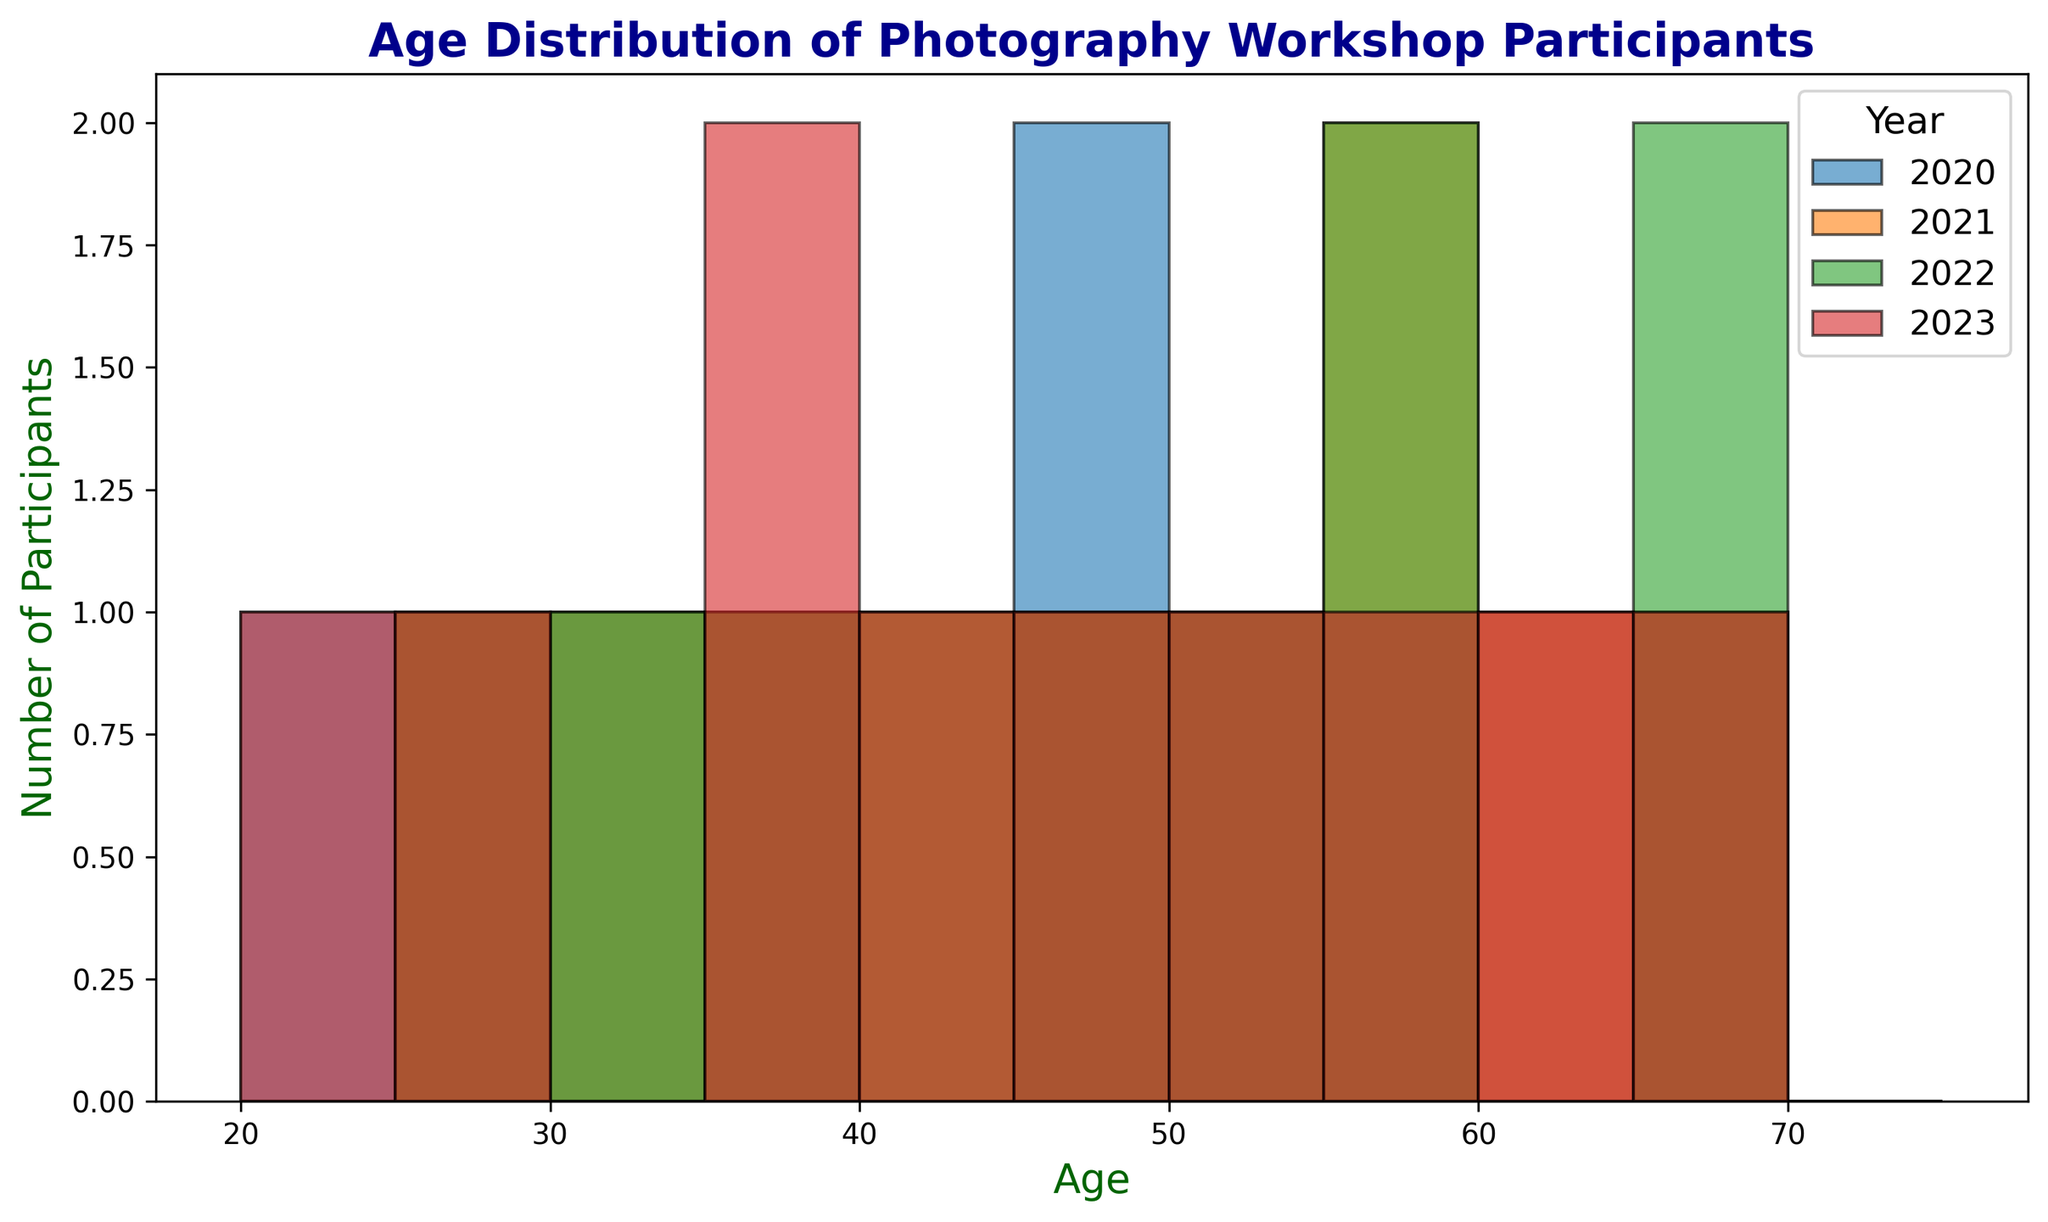What is the most common age group for participants in 2020? Look at the histogram for the year 2020 and identify which age bin has the highest bar. This represents the most common age group.
Answer: 45-50 Which year had the highest number of participants in the age group 55-60? Compare the heights of the bars representing the age group 55-60 for each year. The year with the tallest bar is the answer.
Answer: 2021 What is the smallest age group with participants across all years combined? Review the histogram across all years and find the shortest bar, which will indicate the smallest age group.
Answer: 20-25 Which year has a higher number of participants aged 40-45, 2021 or 2023? Compare the heights of the bars for the age group 40-45 between the years 2021 and 2023. The year with a taller bar has more participants.
Answer: 2023 How many participants were there in the 30-35 age group in 2020 and 2021 combined? Find the heights of the bars for the age group 30-35 in 2020 and 2021, and add them together to get the total number of participants.
Answer: 2 In which age group did the number of participants decrease from 2021 to 2022? Look at the changes in heights of the bars in each age group from 2021 to 2022 and identify the age group where the height is lower in 2022 than in 2021.
Answer: 55-60 For the 50-55 age group, compare the number of participants across all years and identify the year with the least participants. Assess the bar heights for the 50-55 age group for all years in the histogram and identify the shortest bar.
Answer: 2020 What is the difference in the number of participants in the 60-65 age group between 2021 and 2023? Subtract the height of the bar for the 60-65 age group in 2021 from the height of the bar for the same age group in 2023.
Answer: 1 Which year showed the most diverse age distribution, meaning the participants' ages were spread out across many age groups? Identify the year with the histogram bars having relatively even heights spread across multiple age groups rather than one or two dominant age groups.
Answer: 2023 What is the average age of participants in the year 2020? Sum the ages of all participants in 2020 and divide by the number of participants for that year. Calculation: (23+34+45+56+67+29+38+54+47+63) / 10 = 45.6
Answer: 45.6 